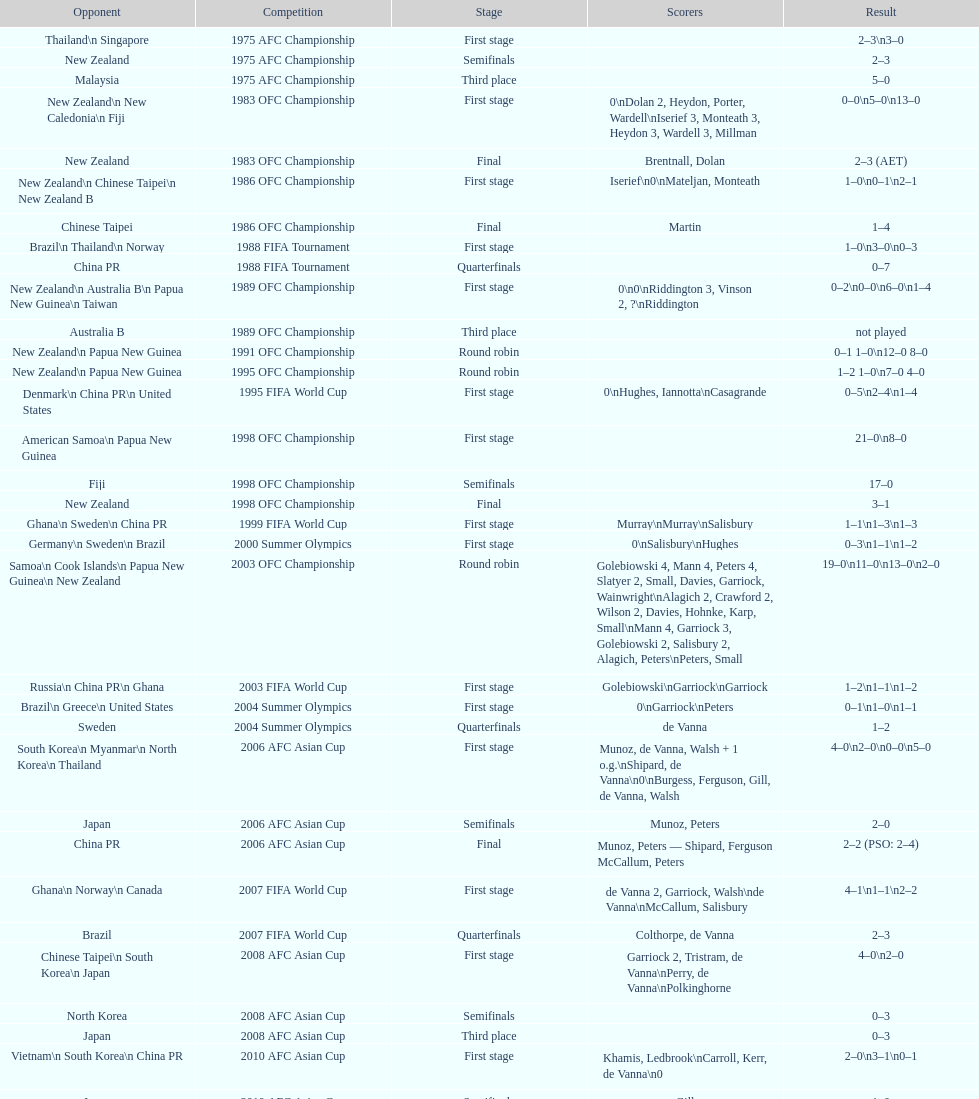What is the total number of competitions? 21. 